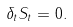<formula> <loc_0><loc_0><loc_500><loc_500>\delta _ { t } S _ { t } = 0 .</formula> 